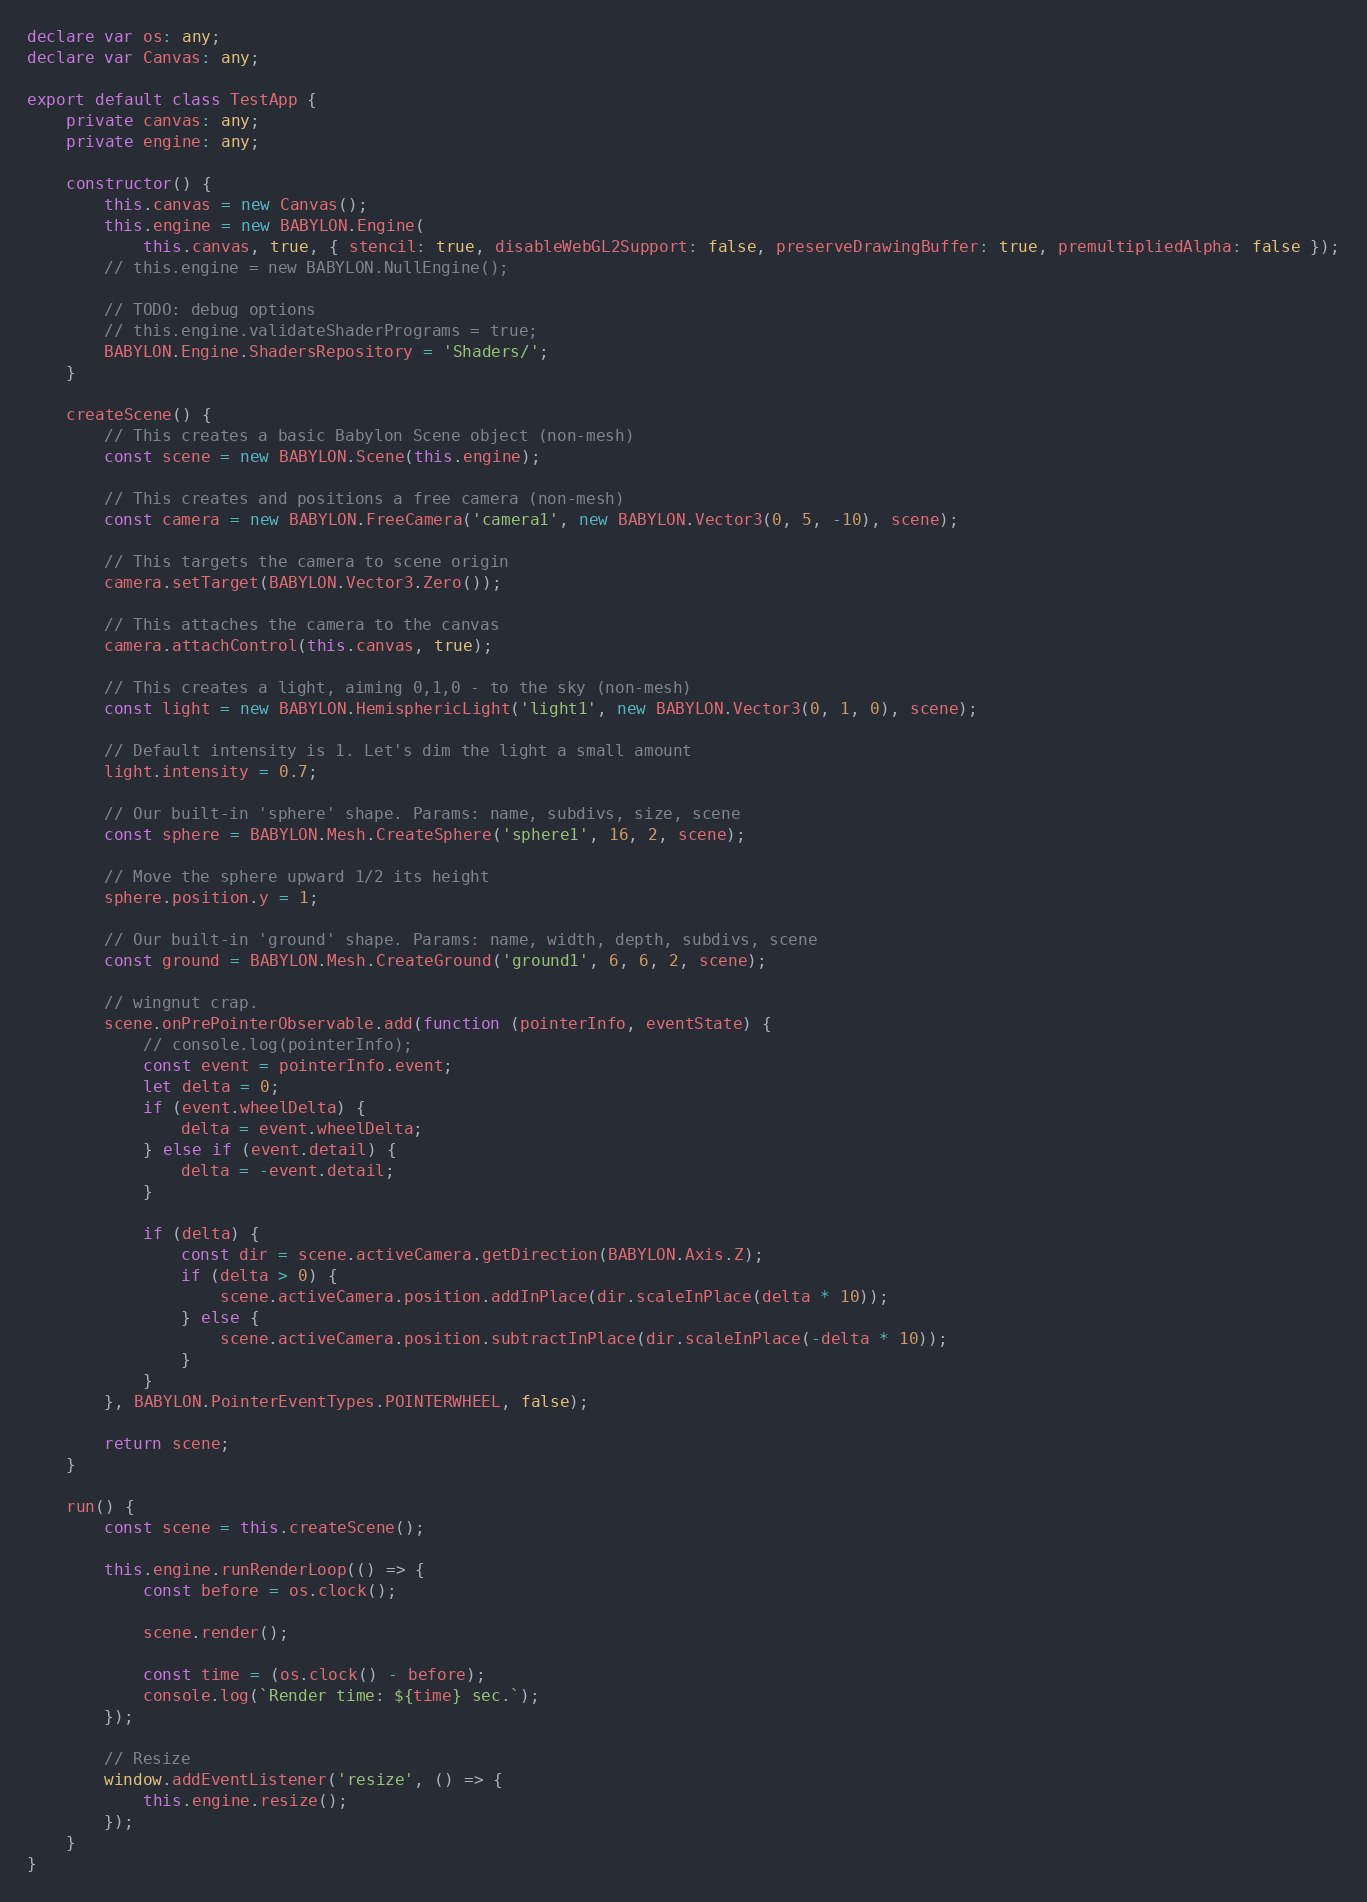Convert code to text. <code><loc_0><loc_0><loc_500><loc_500><_TypeScript_>declare var os: any;
declare var Canvas: any;

export default class TestApp {
    private canvas: any;
    private engine: any;

    constructor() {
        this.canvas = new Canvas();
        this.engine = new BABYLON.Engine(
            this.canvas, true, { stencil: true, disableWebGL2Support: false, preserveDrawingBuffer: true, premultipliedAlpha: false });
        // this.engine = new BABYLON.NullEngine();

        // TODO: debug options
        // this.engine.validateShaderPrograms = true;
        BABYLON.Engine.ShadersRepository = 'Shaders/';
    }

    createScene() {
        // This creates a basic Babylon Scene object (non-mesh)
        const scene = new BABYLON.Scene(this.engine);

        // This creates and positions a free camera (non-mesh)
        const camera = new BABYLON.FreeCamera('camera1', new BABYLON.Vector3(0, 5, -10), scene);

        // This targets the camera to scene origin
        camera.setTarget(BABYLON.Vector3.Zero());

        // This attaches the camera to the canvas
        camera.attachControl(this.canvas, true);

        // This creates a light, aiming 0,1,0 - to the sky (non-mesh)
        const light = new BABYLON.HemisphericLight('light1', new BABYLON.Vector3(0, 1, 0), scene);

        // Default intensity is 1. Let's dim the light a small amount
        light.intensity = 0.7;

        // Our built-in 'sphere' shape. Params: name, subdivs, size, scene
        const sphere = BABYLON.Mesh.CreateSphere('sphere1', 16, 2, scene);

        // Move the sphere upward 1/2 its height
        sphere.position.y = 1;

        // Our built-in 'ground' shape. Params: name, width, depth, subdivs, scene
        const ground = BABYLON.Mesh.CreateGround('ground1', 6, 6, 2, scene);

        // wingnut crap.
        scene.onPrePointerObservable.add(function (pointerInfo, eventState) {
            // console.log(pointerInfo);
            const event = pointerInfo.event;
            let delta = 0;
            if (event.wheelDelta) {
                delta = event.wheelDelta;
            } else if (event.detail) {
                delta = -event.detail;
            }

            if (delta) {
                const dir = scene.activeCamera.getDirection(BABYLON.Axis.Z);
                if (delta > 0) {
                    scene.activeCamera.position.addInPlace(dir.scaleInPlace(delta * 10));
                } else {
                    scene.activeCamera.position.subtractInPlace(dir.scaleInPlace(-delta * 10));
                }
            }
        }, BABYLON.PointerEventTypes.POINTERWHEEL, false);

        return scene;
    }

    run() {
        const scene = this.createScene();

        this.engine.runRenderLoop(() => {
            const before = os.clock();

            scene.render();

            const time = (os.clock() - before);
            console.log(`Render time: ${time} sec.`);
        });

        // Resize
        window.addEventListener('resize', () => {
            this.engine.resize();
        });
    }
}
</code> 